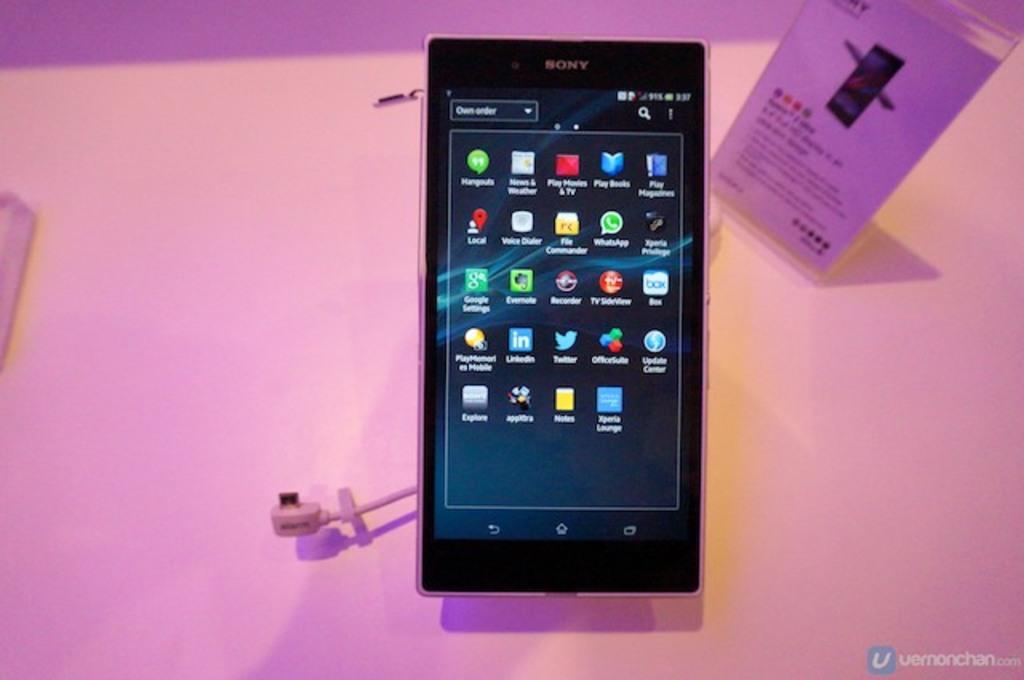What is the top left app called?
Your answer should be very brief. Hangouts. Who made this phone?
Make the answer very short. Sony. 